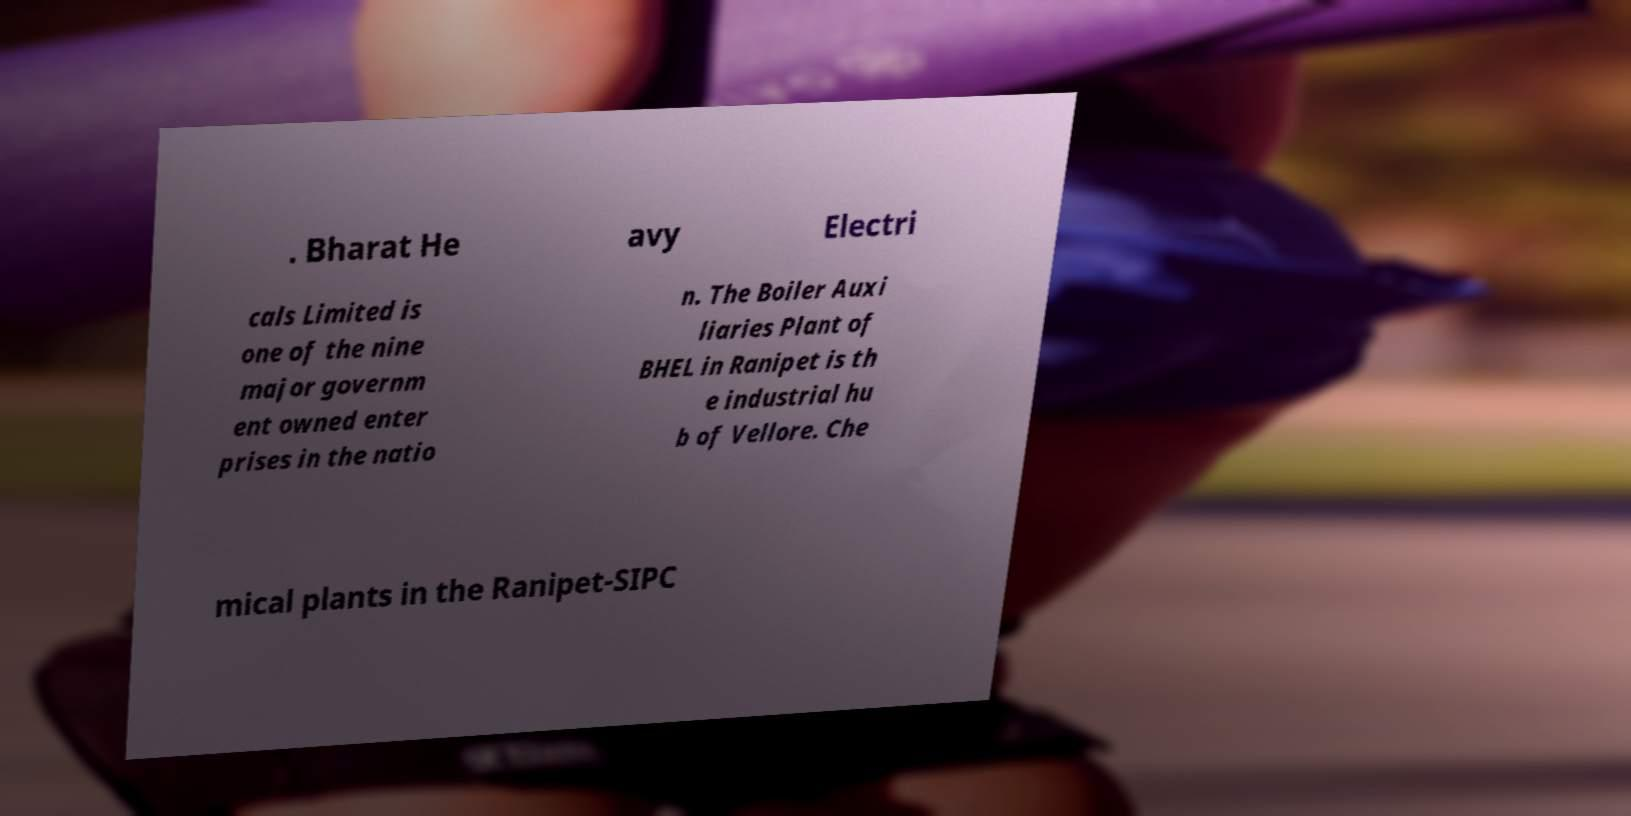For documentation purposes, I need the text within this image transcribed. Could you provide that? . Bharat He avy Electri cals Limited is one of the nine major governm ent owned enter prises in the natio n. The Boiler Auxi liaries Plant of BHEL in Ranipet is th e industrial hu b of Vellore. Che mical plants in the Ranipet-SIPC 